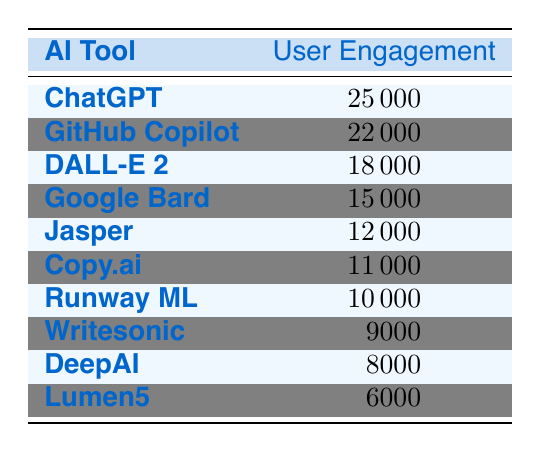What is the User Engagement Level for ChatGPT? From the table, the User Engagement Level specifically listed for ChatGPT is directly available in the row corresponding to that tool.
Answer: 25000 Which AI tool has the highest User Engagement Level? The row for ChatGPT shows the highest engagement level of 25000, more than any other tool listed in the table.
Answer: ChatGPT What is the difference in User Engagement Level between GitHub Copilot and DeepAI? GitHub Copilot has an engagement level of 22000 and DeepAI has 8000. Thus, the difference is calculated as 22000 - 8000 = 14000.
Answer: 14000 Is DALL-E 2 more engaging than Jasper? DALL-E 2 has a User Engagement Level of 18000 while Jasper has 12000. Since 18000 is greater than 12000, DALL-E 2 is indeed more engaging than Jasper.
Answer: Yes What is the average User Engagement Level of the tools listed in the table? To find the average, sum all levels: (25000 + 22000 + 18000 + 15000 + 12000 + 11000 + 10000 + 9000 + 8000 + 6000) = 111000. There are 10 tools, so the average is 111000/10 = 11100.
Answer: 11100 Which tool has a User Engagement Level below 10000? From the table, Lumen5 has a User Engagement Level of 6000, while DeepAI has 8000, both of which are below 10000.
Answer: Lumen5 and DeepAI If you combine the User Engagement Levels of Copy.ai and Runway ML, what is the total? Copy.ai has an engagement level of 11000 and Runway ML has 10000. Therefore, their combined engagement is 11000 + 10000 = 21000.
Answer: 21000 Is it true that Google Bard has more engagement than Writesonic? Google Bard has a User Engagement Level of 15000, whereas Writesonic has 9000. Since 15000 is greater than 9000, the statement is true.
Answer: Yes Which two tools have the lowest User Engagement Levels, and what are those values? Reviewing the table, Lumen5 has 6000 and DeepAI has 8000, making these the two tools with the lowest levels.
Answer: Lumen5 (6000) and DeepAI (8000) 